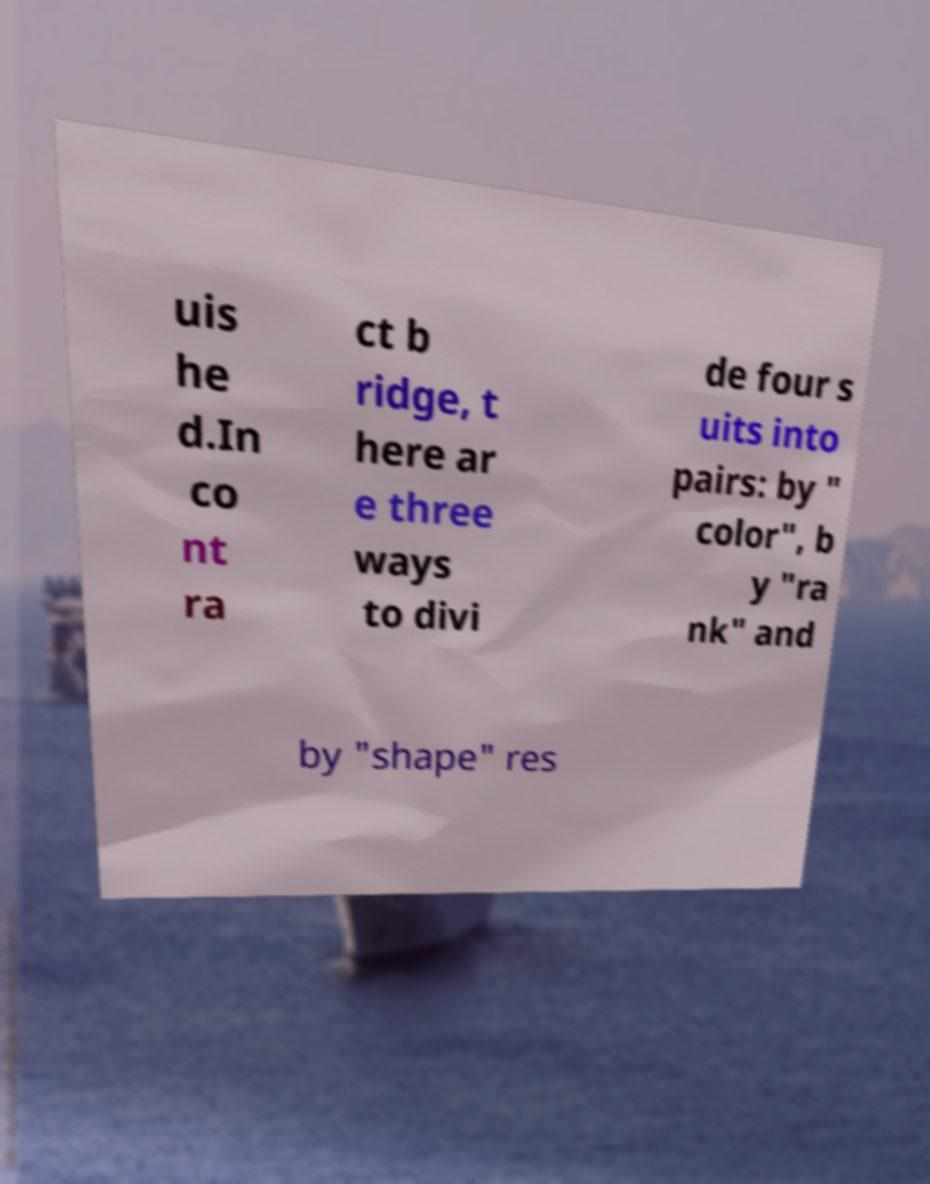Can you accurately transcribe the text from the provided image for me? uis he d.In co nt ra ct b ridge, t here ar e three ways to divi de four s uits into pairs: by " color", b y "ra nk" and by "shape" res 